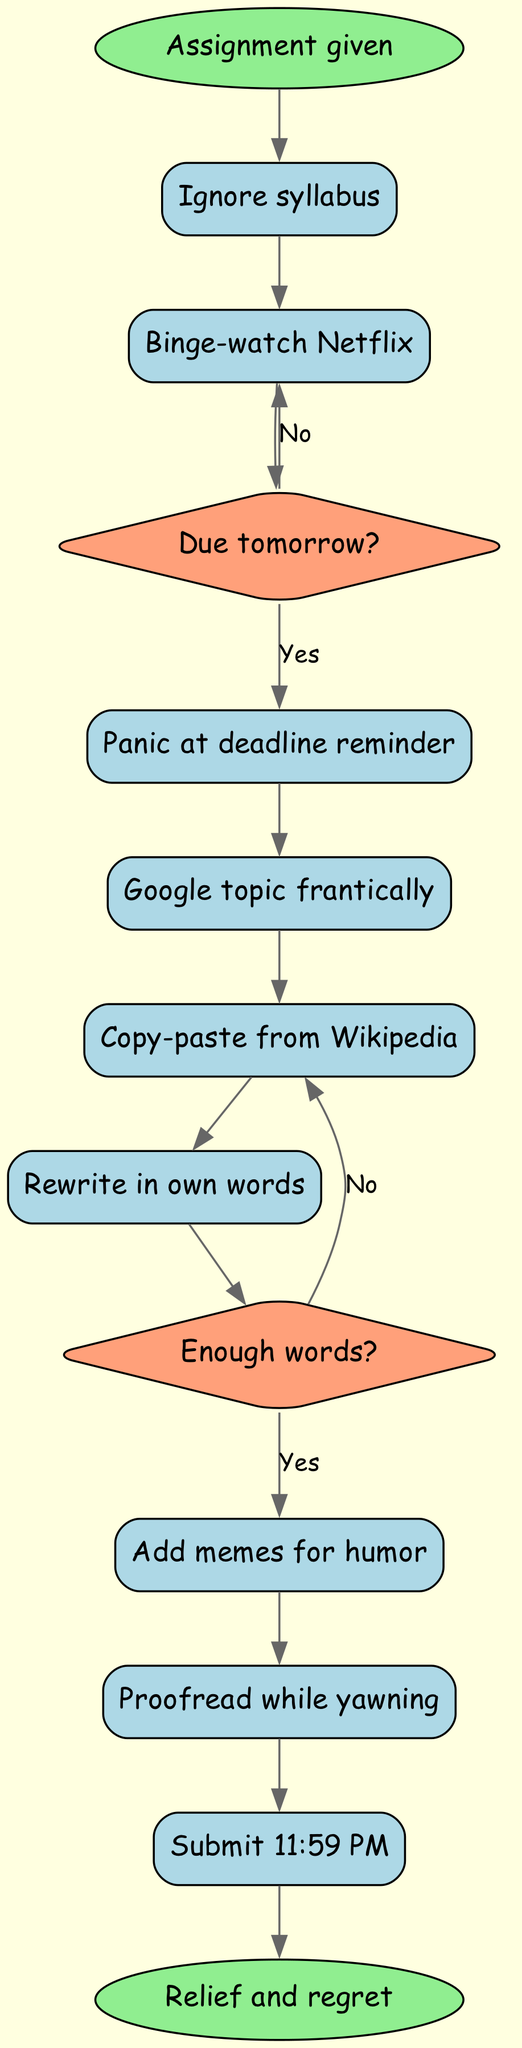What is the starting node in the diagram? The starting node is the first node in the diagram, labeled "Assignment given."
Answer: Assignment given How many activities are present in the diagram? The diagram lists nine activities, which can be counted in the "activities" section of the data provided.
Answer: 9 What happens immediately after "Ignore syllabus"? After "Ignore syllabus," the next activity listed is "Binge-watch Netflix." This is a direct transition from one activity to another as represented by the edges in the diagram.
Answer: Binge-watch Netflix What is the outcome if the answer to "Due tomorrow?" is "No"? If "No," the flow continues to "Binge-watch Netflix," as indicated in the decision structure of the diagram.
Answer: Binge-watch Netflix How do you get to "Proofread while yawning"? To reach "Proofread while yawning," you must follow the path starting from "Copy-paste from Wikipedia" after the decision "Enough words?" returns "No." This leads directly to the proofreading activity.
Answer: Copy-paste from Wikipedia What is the final node of the diagram? The final node represents the end result of the entire activity's flow, labeled "Relief and regret." This can be confirmed by checking the last node in the diagram structure.
Answer: Relief and regret Which activity comes after "Rewrite in own words"? The activity that follows "Rewrite in own words" in the sequence is "Add memes for humor," demonstrating the flow of the activities after rewriting.
Answer: Add memes for humor What are the two options after "Panic at deadline reminder"? The options are "Panic at deadline reminder" leads to either "Panic at deadline reminder" if "Due tomorrow?" is "Yes" or back to "Binge-watch Netflix" if "No." This shows the decision-making process being highlighted.
Answer: Panic at deadline reminder, Binge-watch Netflix What decision follows the activity "Rewrite in own words"? The activity that follows "Rewrite in own words" is a decision, specifically the question "Enough words?" which determines the next step in the process. This can be confirmed by following the sequence in the diagram.
Answer: Enough words? 